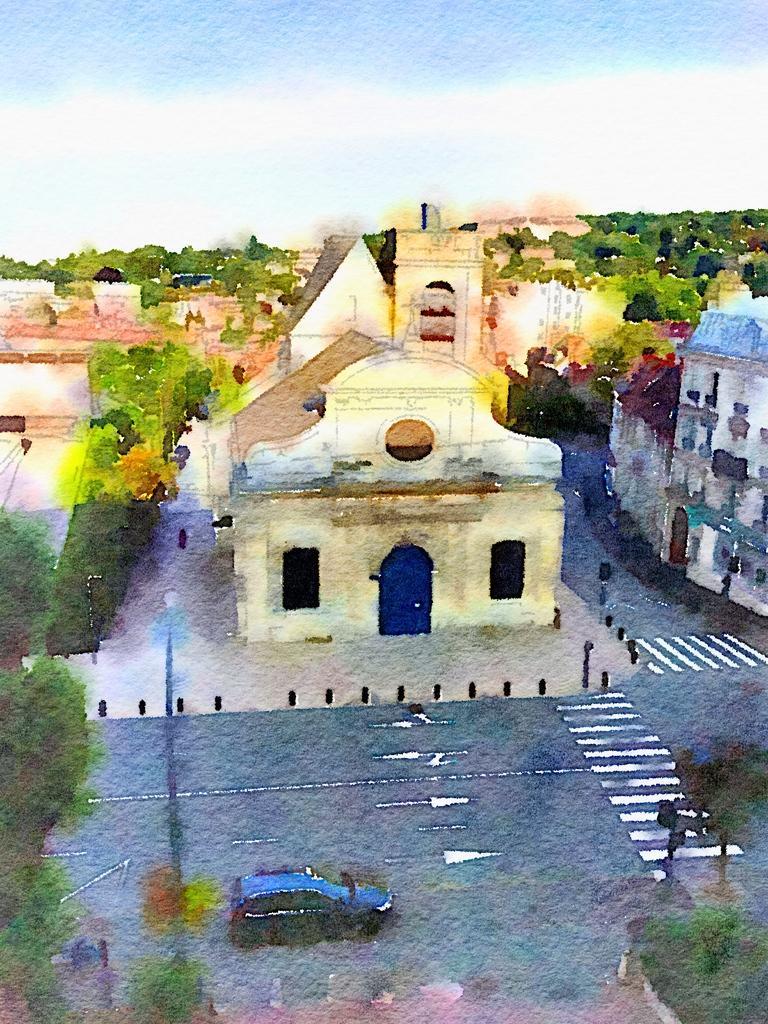How would you summarize this image in a sentence or two? This picture shows a painting. We see houses, Trees and a car on the road and we see pole light and a blue cloudy sky. 